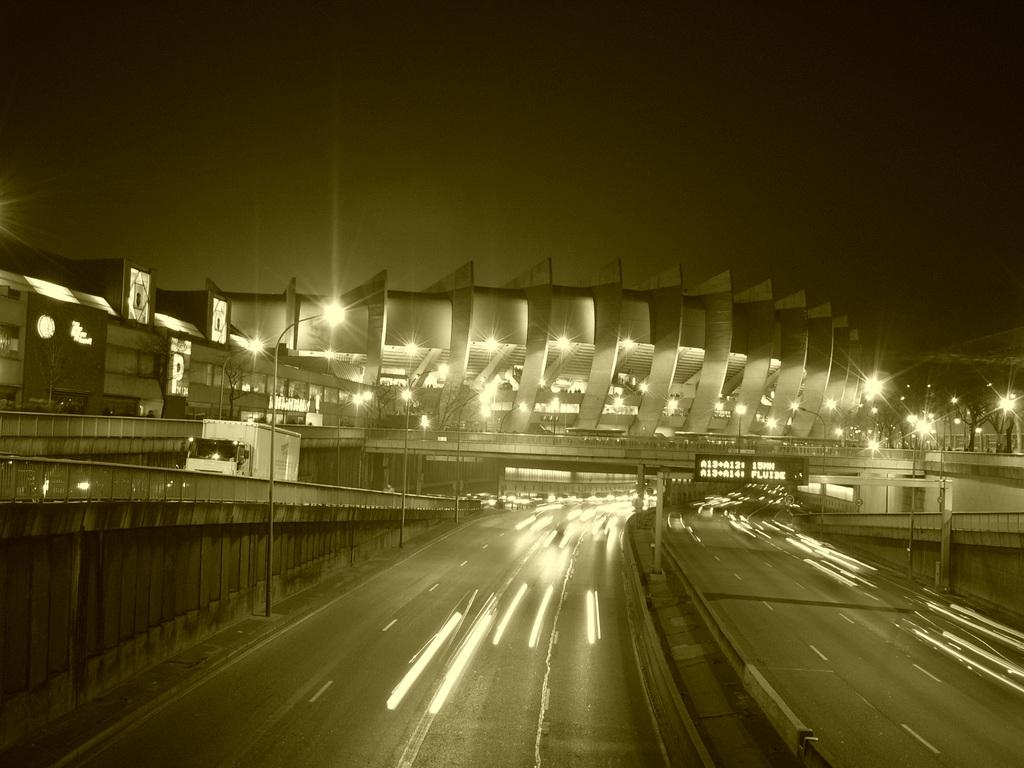What can be seen on the road in the image? There are vehicles on the road in the image. What structures are located beside the road? There are poles, lights, and buildings beside the road in the image. What type of infrastructure is present over the road in the image? There is a bridge over the road in the image. How does the can breathe while standing on the road in the image? There is no can present in the image, and therefore no such activity can be observed. 